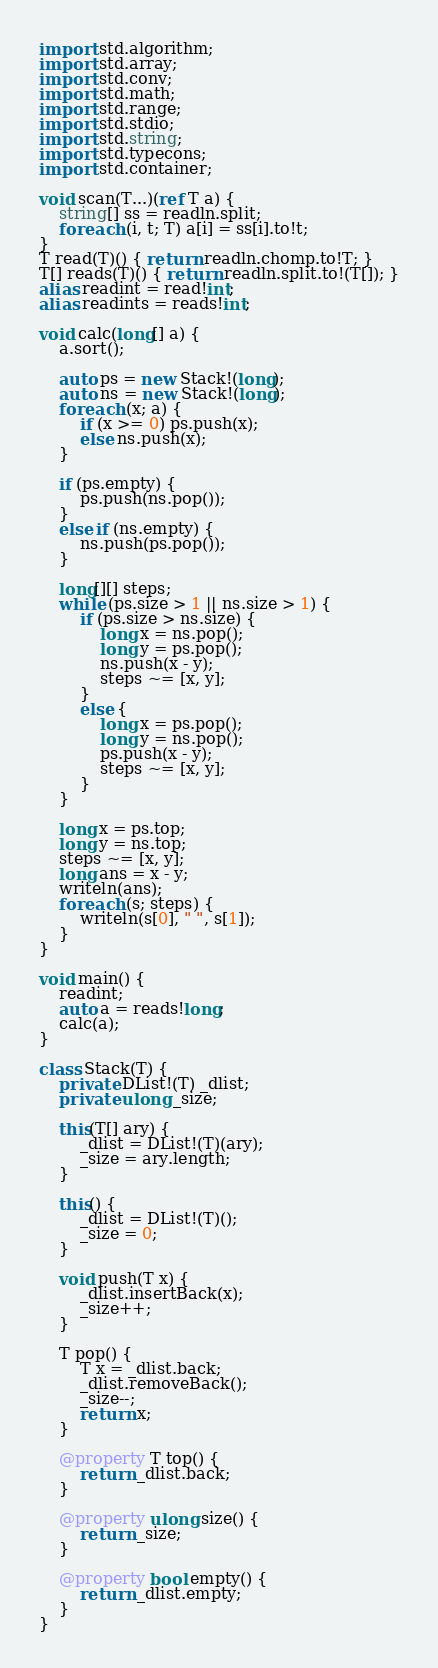<code> <loc_0><loc_0><loc_500><loc_500><_D_>import std.algorithm;
import std.array;
import std.conv;
import std.math;
import std.range;
import std.stdio;
import std.string;
import std.typecons;
import std.container;

void scan(T...)(ref T a) {
    string[] ss = readln.split;
    foreach (i, t; T) a[i] = ss[i].to!t;
}
T read(T)() { return readln.chomp.to!T; }
T[] reads(T)() { return readln.split.to!(T[]); }
alias readint = read!int;
alias readints = reads!int;

void calc(long[] a) {
    a.sort();

    auto ps = new Stack!(long);
    auto ns = new Stack!(long);
    foreach (x; a) {
        if (x >= 0) ps.push(x);
        else ns.push(x);
    }

    if (ps.empty) {
        ps.push(ns.pop());
    }
    else if (ns.empty) {
        ns.push(ps.pop());
    }

    long[][] steps;
    while (ps.size > 1 || ns.size > 1) {
        if (ps.size > ns.size) {
            long x = ns.pop();
            long y = ps.pop();
            ns.push(x - y);
            steps ~= [x, y];
        }
        else {
            long x = ps.pop();
            long y = ns.pop();
            ps.push(x - y);
            steps ~= [x, y];
        }
    }

    long x = ps.top;
    long y = ns.top;
    steps ~= [x, y];
    long ans = x - y;
    writeln(ans);
    foreach (s; steps) {
        writeln(s[0], " ", s[1]);
    }
}

void main() {
    readint;
    auto a = reads!long;
    calc(a);
}

class Stack(T) {
    private DList!(T) _dlist;
    private ulong _size;

    this(T[] ary) {
        _dlist = DList!(T)(ary);
        _size = ary.length;
    }

    this() {
        _dlist = DList!(T)();
        _size = 0;
    }

    void push(T x) {
        _dlist.insertBack(x);
        _size++;
    }

    T pop() {
        T x = _dlist.back;
        _dlist.removeBack();
        _size--;
        return x;
    }

    @property T top() {
        return _dlist.back;
    }

    @property ulong size() {
        return _size;
    }

    @property bool empty() {
        return _dlist.empty;
    }
}
</code> 